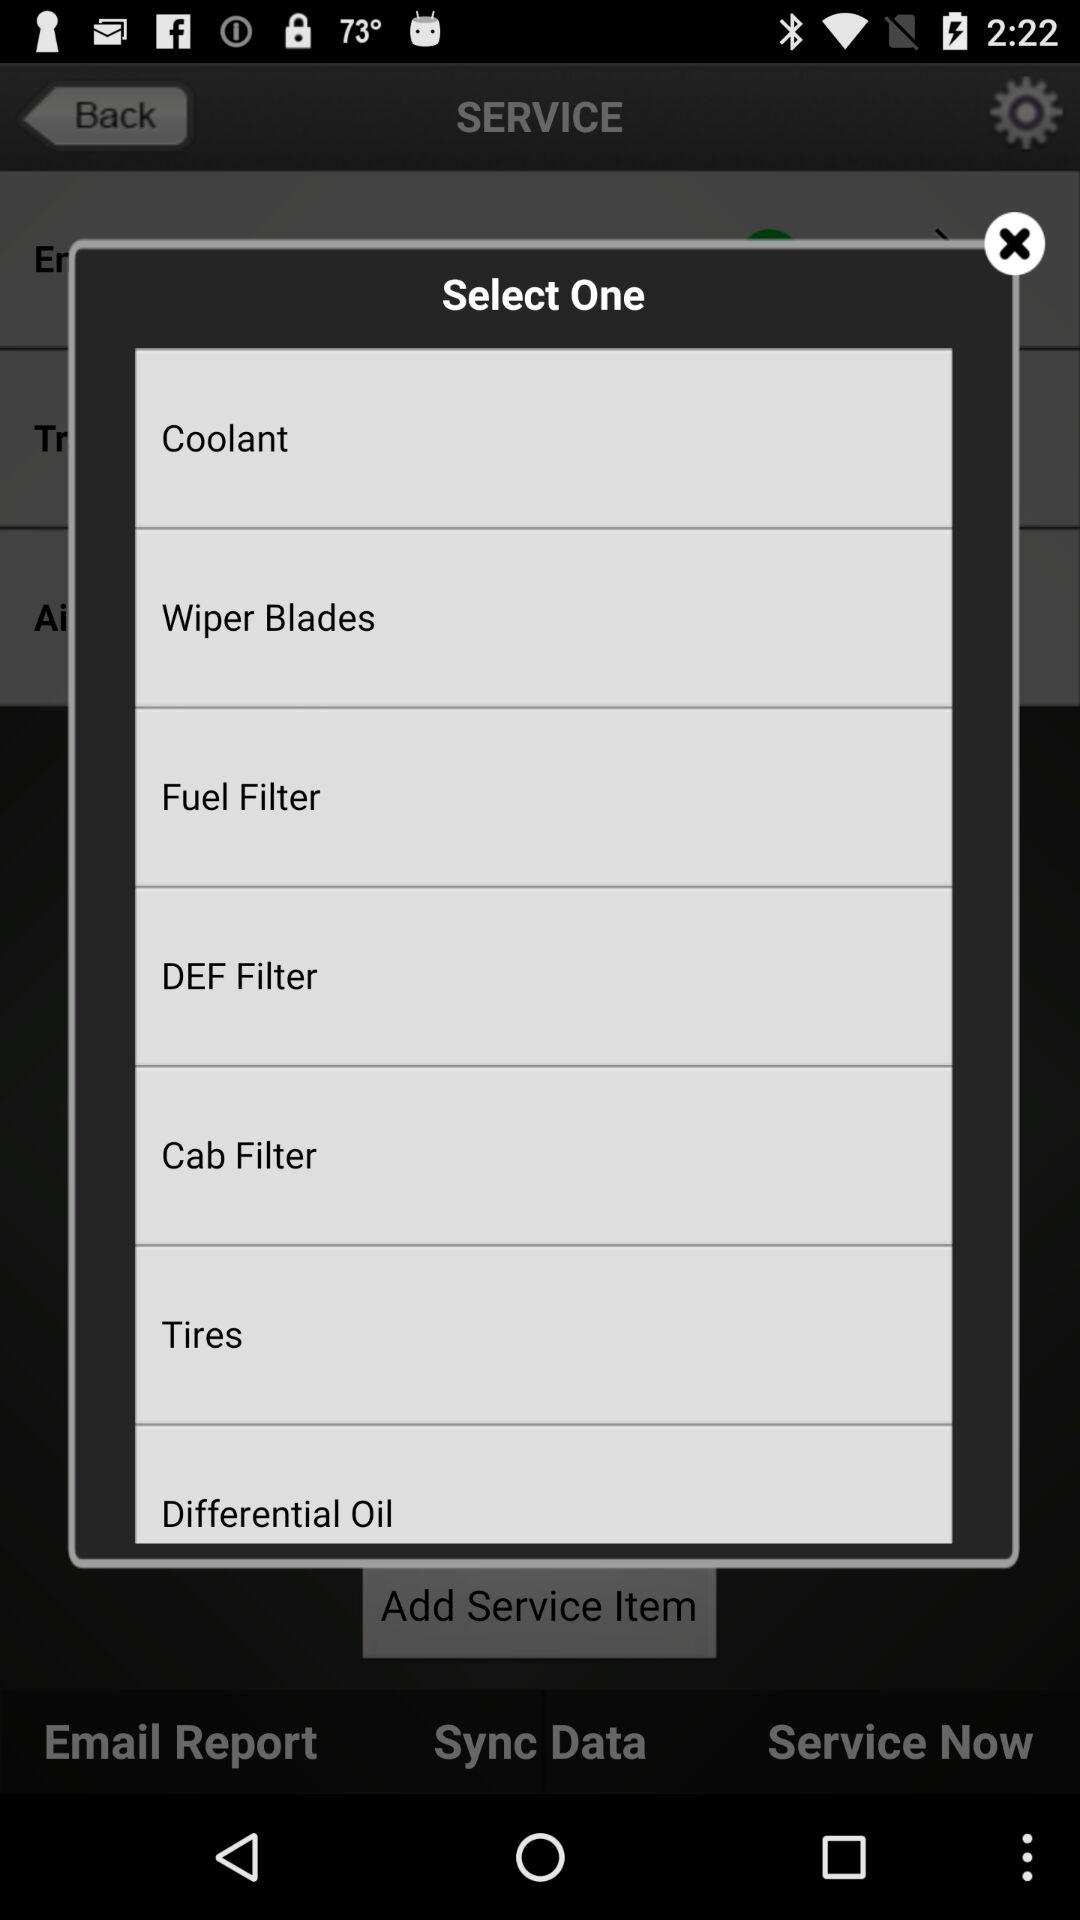What are the available vehicle spare parts? The available vehicle spare parts are coolant, wiper blades, fuel filter, DEF filter, cabin filter, tires and differential oil. 